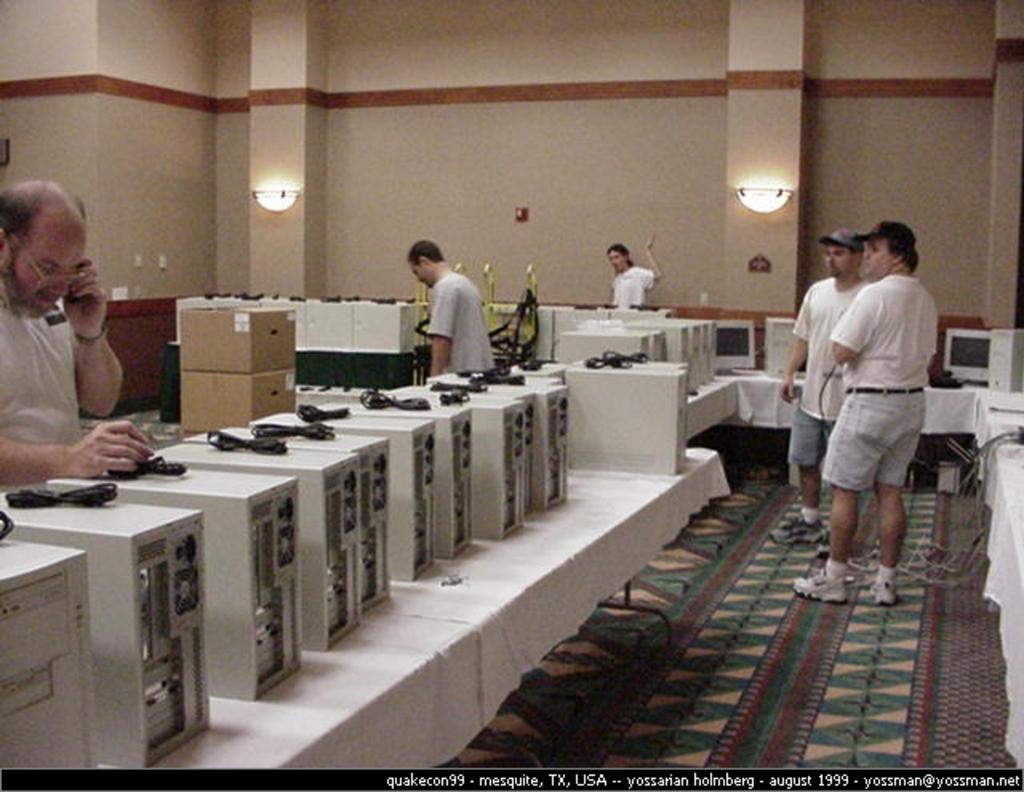How would you summarize this image in a sentence or two? In this image there are tables. There are clothes spread on the tables. There are boxes, cable wires, monitors and CPUs on the table. Beside the tables there are a few people standing. In the background there is a wall. There are lamps on the wall. 